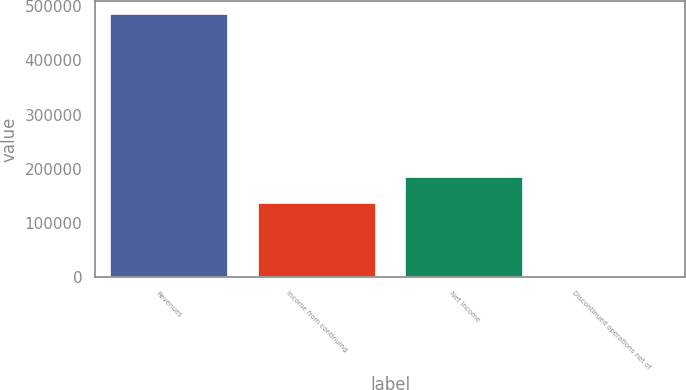<chart> <loc_0><loc_0><loc_500><loc_500><bar_chart><fcel>Revenues<fcel>Income from continuing<fcel>Net income<fcel>Discontinued operations net of<nl><fcel>485443<fcel>136877<fcel>185281<fcel>1399<nl></chart> 